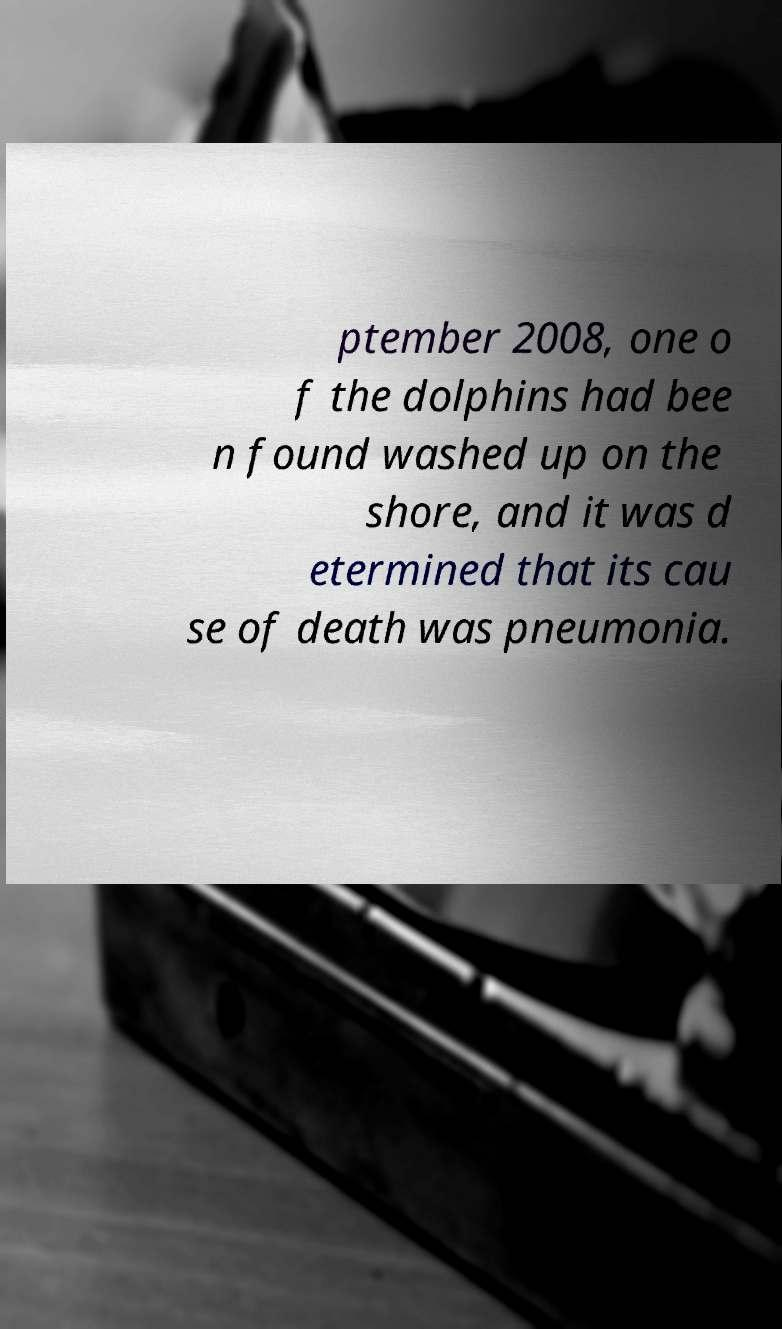Can you read and provide the text displayed in the image?This photo seems to have some interesting text. Can you extract and type it out for me? ptember 2008, one o f the dolphins had bee n found washed up on the shore, and it was d etermined that its cau se of death was pneumonia. 